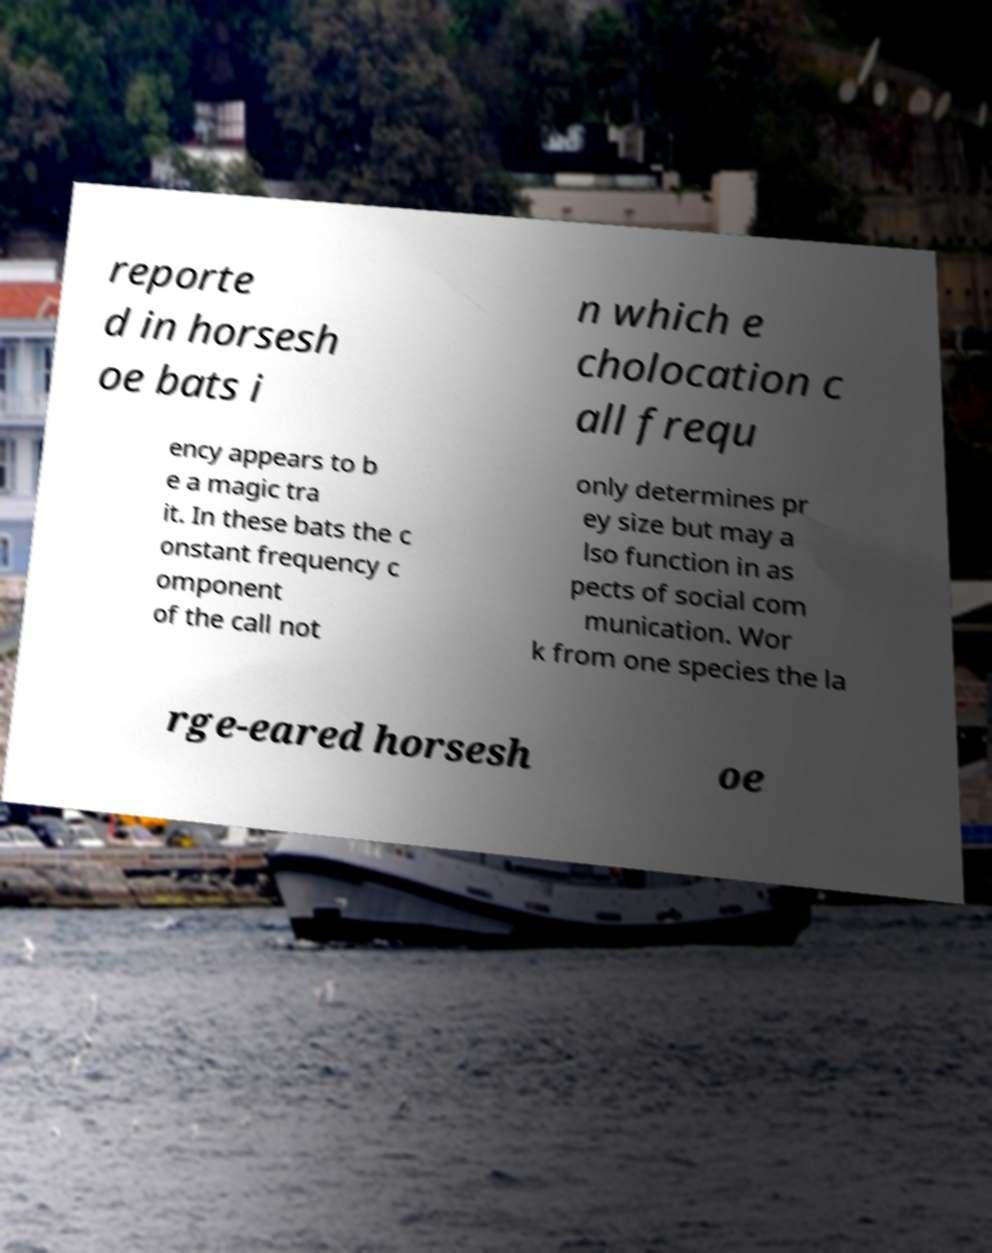I need the written content from this picture converted into text. Can you do that? reporte d in horsesh oe bats i n which e cholocation c all frequ ency appears to b e a magic tra it. In these bats the c onstant frequency c omponent of the call not only determines pr ey size but may a lso function in as pects of social com munication. Wor k from one species the la rge-eared horsesh oe 